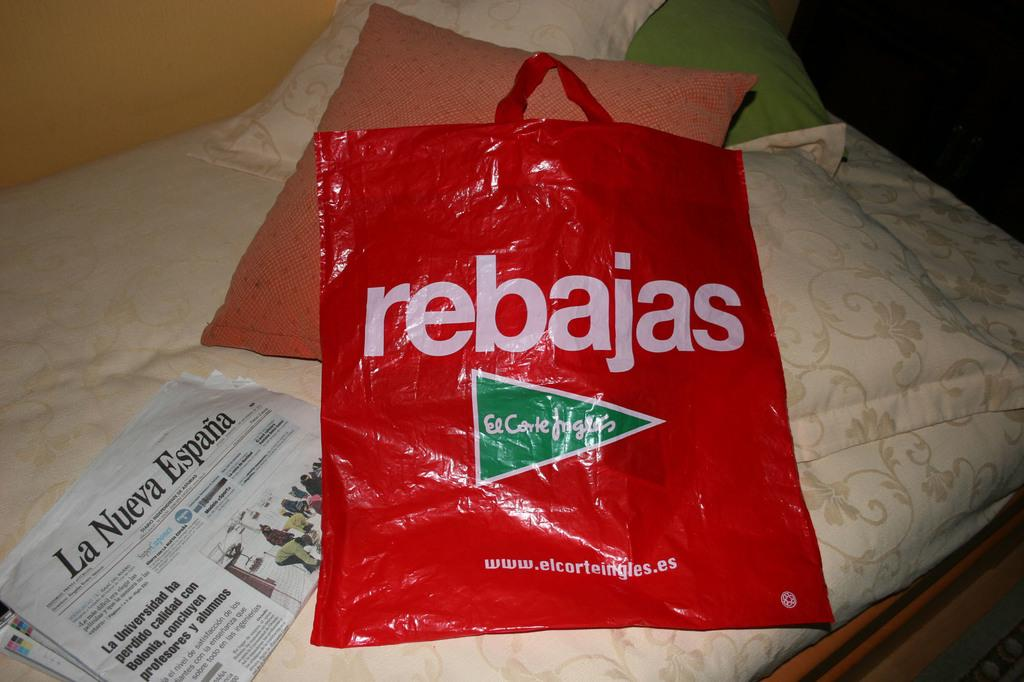What is placed on the red carry bag in the image? There is a newspaper on the carry bag. What else can be seen on the bed in the image? There are pillows on the bed. How would you describe the background of the image? The background of the image is dark in color. Is there any quicksand visible in the image? No, there is no quicksand present in the image. How many quinces are on the bed in the image? There are no quinces visible in the image. 